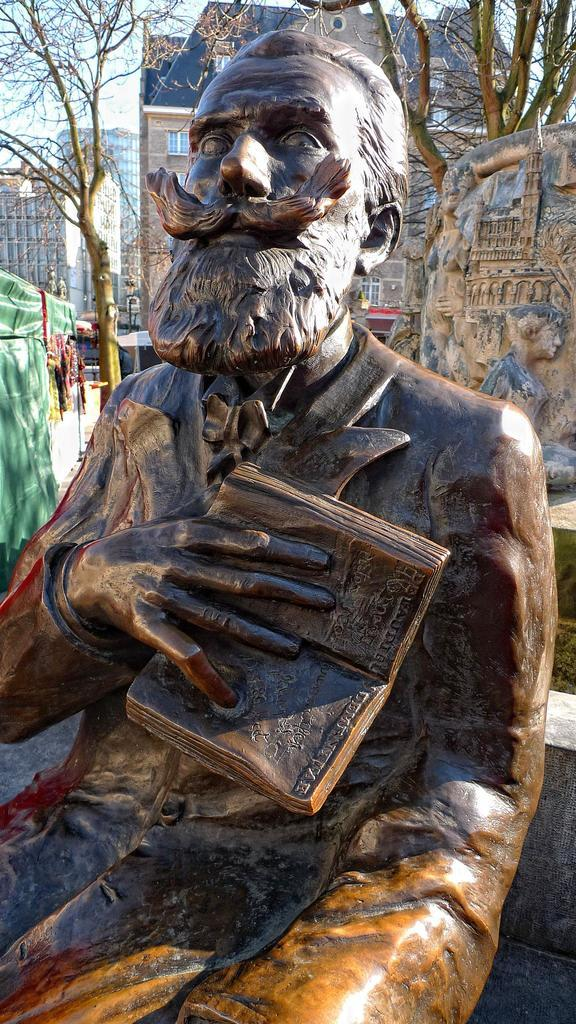What is the main subject in the center of the image? There is a statue in the center of the image. What can be seen in the background of the image? There are buildings and trees in the background of the image. Are there any other sculptures or statues visible in the image? Yes, there is at least one sculpture in the background of the image. What type of boat can be seen in the image? There is no boat present in the image. What is the statue doing in space in the image? The image does not depict a statue in space; it is located in the center of the image on Earth. 